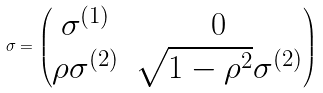Convert formula to latex. <formula><loc_0><loc_0><loc_500><loc_500>\sigma = \begin{pmatrix} \sigma ^ { ( 1 ) } & 0 \\ \rho \sigma ^ { ( 2 ) } & \sqrt { 1 - \rho ^ { 2 } } \sigma ^ { ( 2 ) } \end{pmatrix}</formula> 